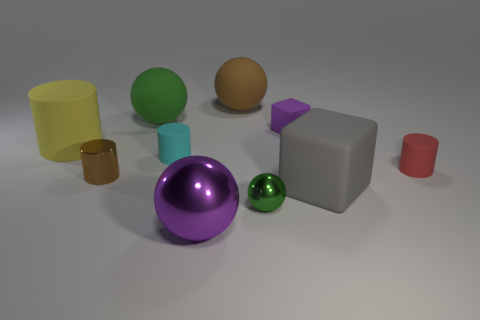Does the big metal object have the same color as the tiny cube?
Your response must be concise. Yes. What is the material of the gray object?
Provide a short and direct response. Rubber. What number of tiny brown rubber objects are there?
Offer a very short reply. 0. Is the color of the small metal object behind the big gray thing the same as the matte ball on the right side of the small cyan cylinder?
Make the answer very short. Yes. There is a metallic sphere that is the same color as the tiny block; what is its size?
Ensure brevity in your answer.  Large. How many other things are the same size as the yellow matte object?
Your response must be concise. 4. What is the color of the block that is behind the red cylinder?
Provide a succinct answer. Purple. Does the green thing that is to the right of the big brown sphere have the same material as the small brown cylinder?
Offer a terse response. Yes. How many objects are behind the big gray cube and left of the tiny green sphere?
Provide a short and direct response. 5. What is the color of the matte cylinder on the left side of the big rubber sphere left of the ball in front of the tiny green shiny thing?
Offer a terse response. Yellow. 